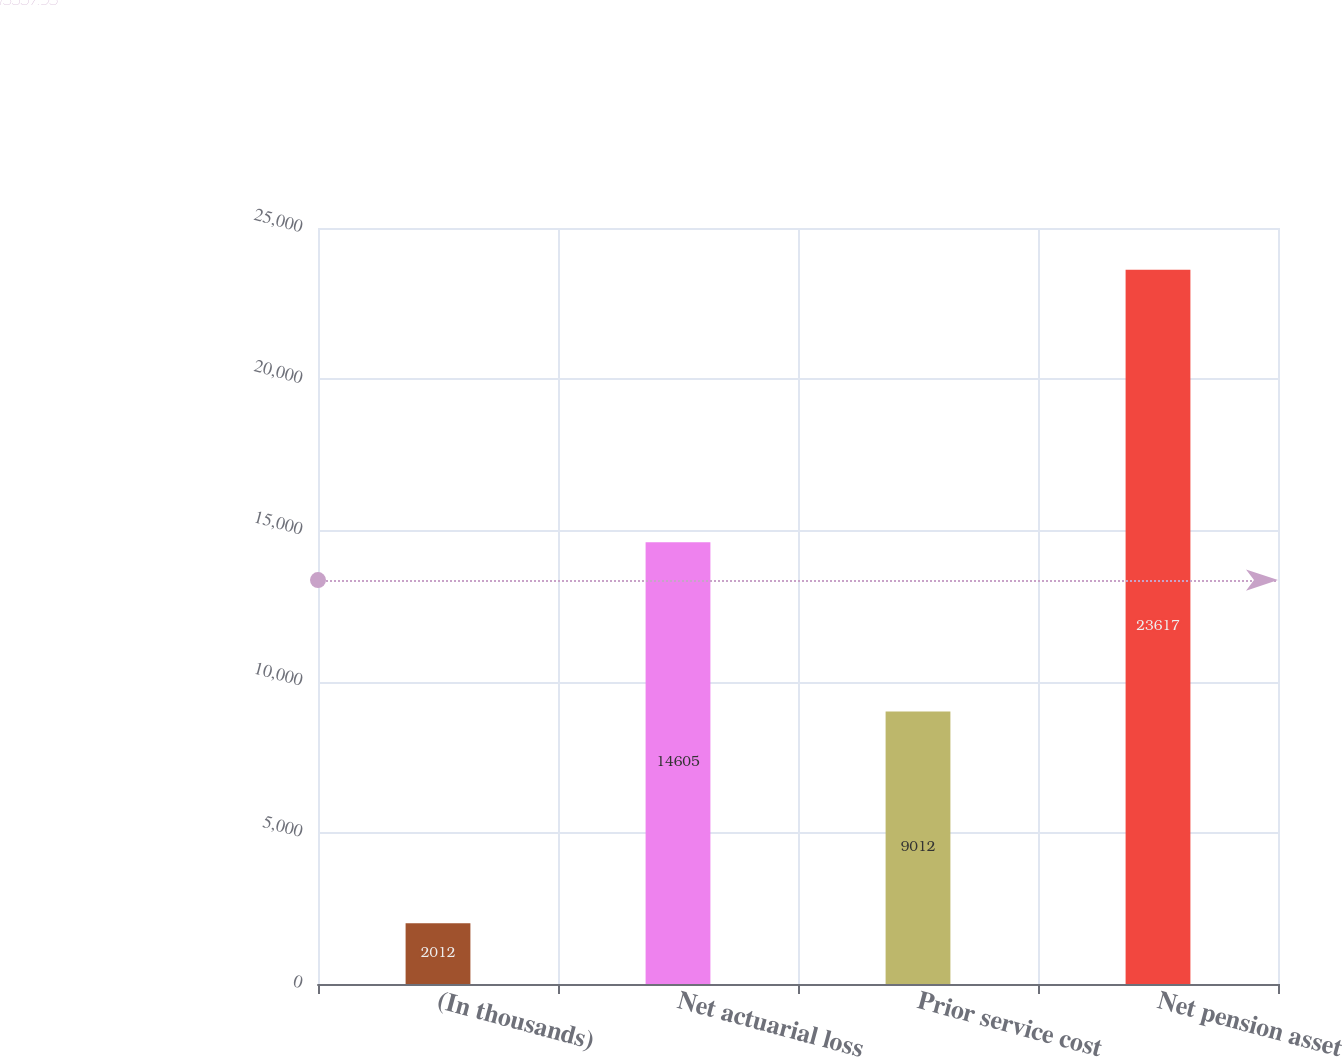Convert chart to OTSL. <chart><loc_0><loc_0><loc_500><loc_500><bar_chart><fcel>(In thousands)<fcel>Net actuarial loss<fcel>Prior service cost<fcel>Net pension asset<nl><fcel>2012<fcel>14605<fcel>9012<fcel>23617<nl></chart> 